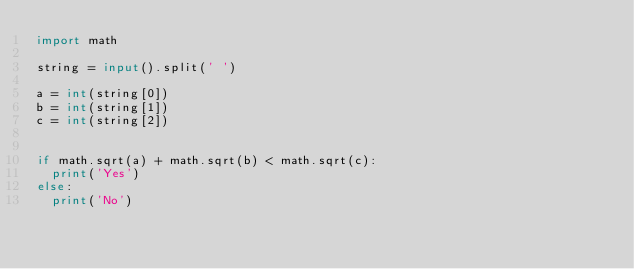Convert code to text. <code><loc_0><loc_0><loc_500><loc_500><_Python_>import math
 
string = input().split(' ')
 
a = int(string[0])
b = int(string[1])
c = int(string[2])
 

if math.sqrt(a) + math.sqrt(b) < math.sqrt(c):
  print('Yes')
else:
  print('No')</code> 